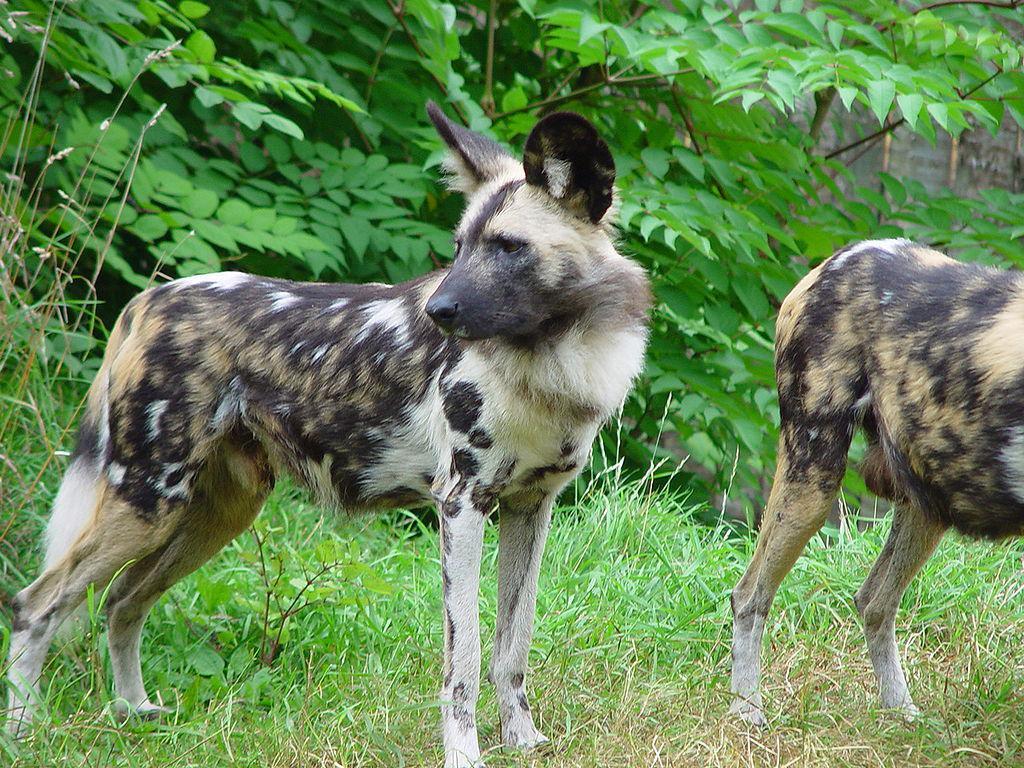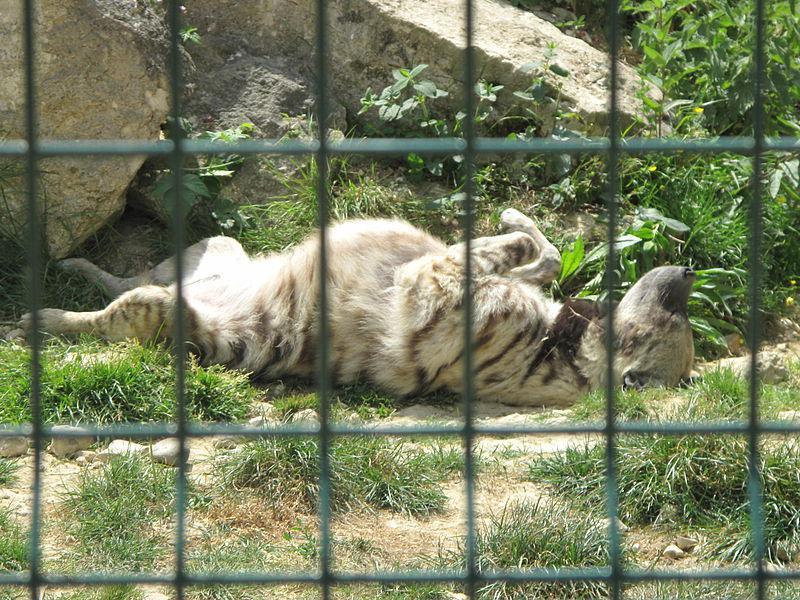The first image is the image on the left, the second image is the image on the right. For the images shown, is this caption "There is only one hyena in the left-hand image." true? Answer yes or no. No. The first image is the image on the left, the second image is the image on the right. Considering the images on both sides, is "There are two animals in the image on the left." valid? Answer yes or no. Yes. 